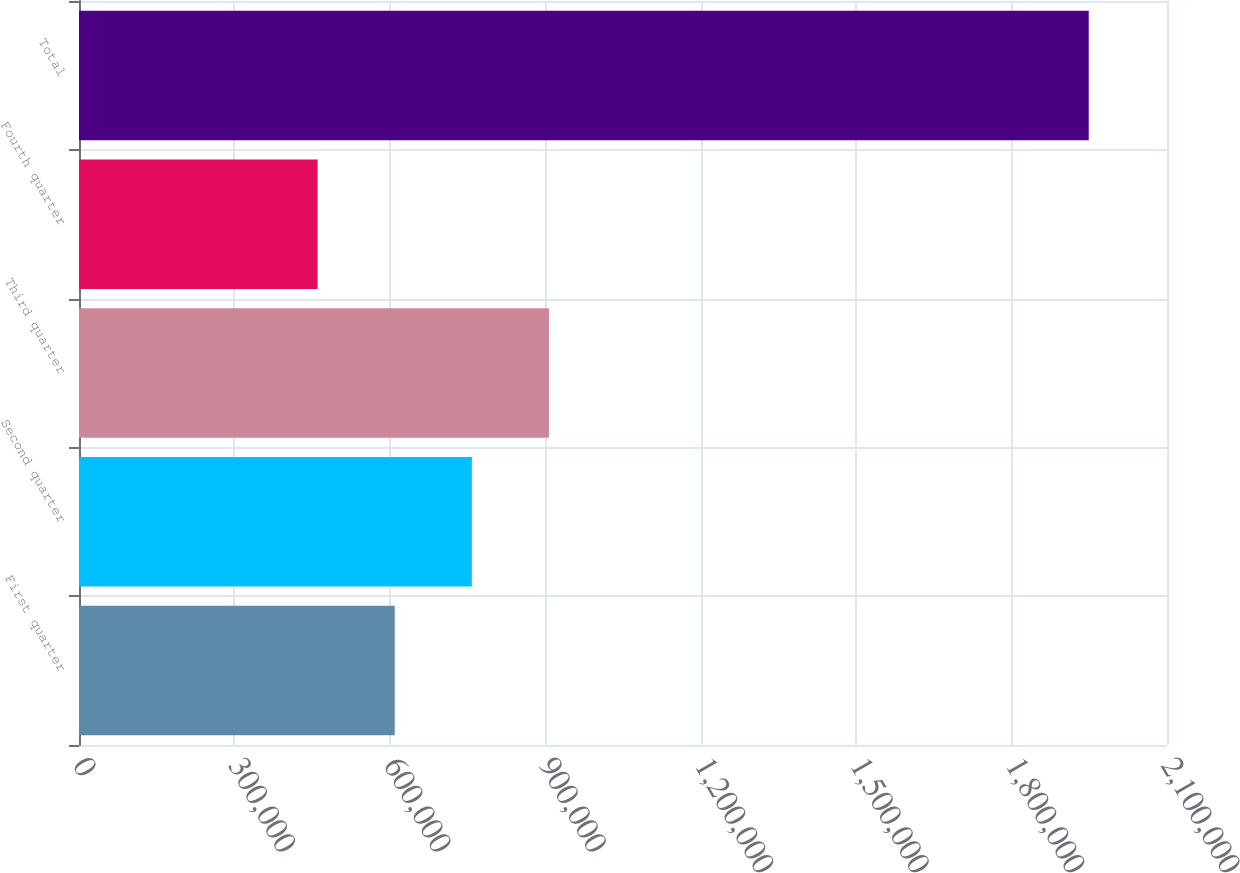Convert chart. <chart><loc_0><loc_0><loc_500><loc_500><bar_chart><fcel>First quarter<fcel>Second quarter<fcel>Third quarter<fcel>Fourth quarter<fcel>Total<nl><fcel>609408<fcel>758244<fcel>907081<fcel>460572<fcel>1.94893e+06<nl></chart> 